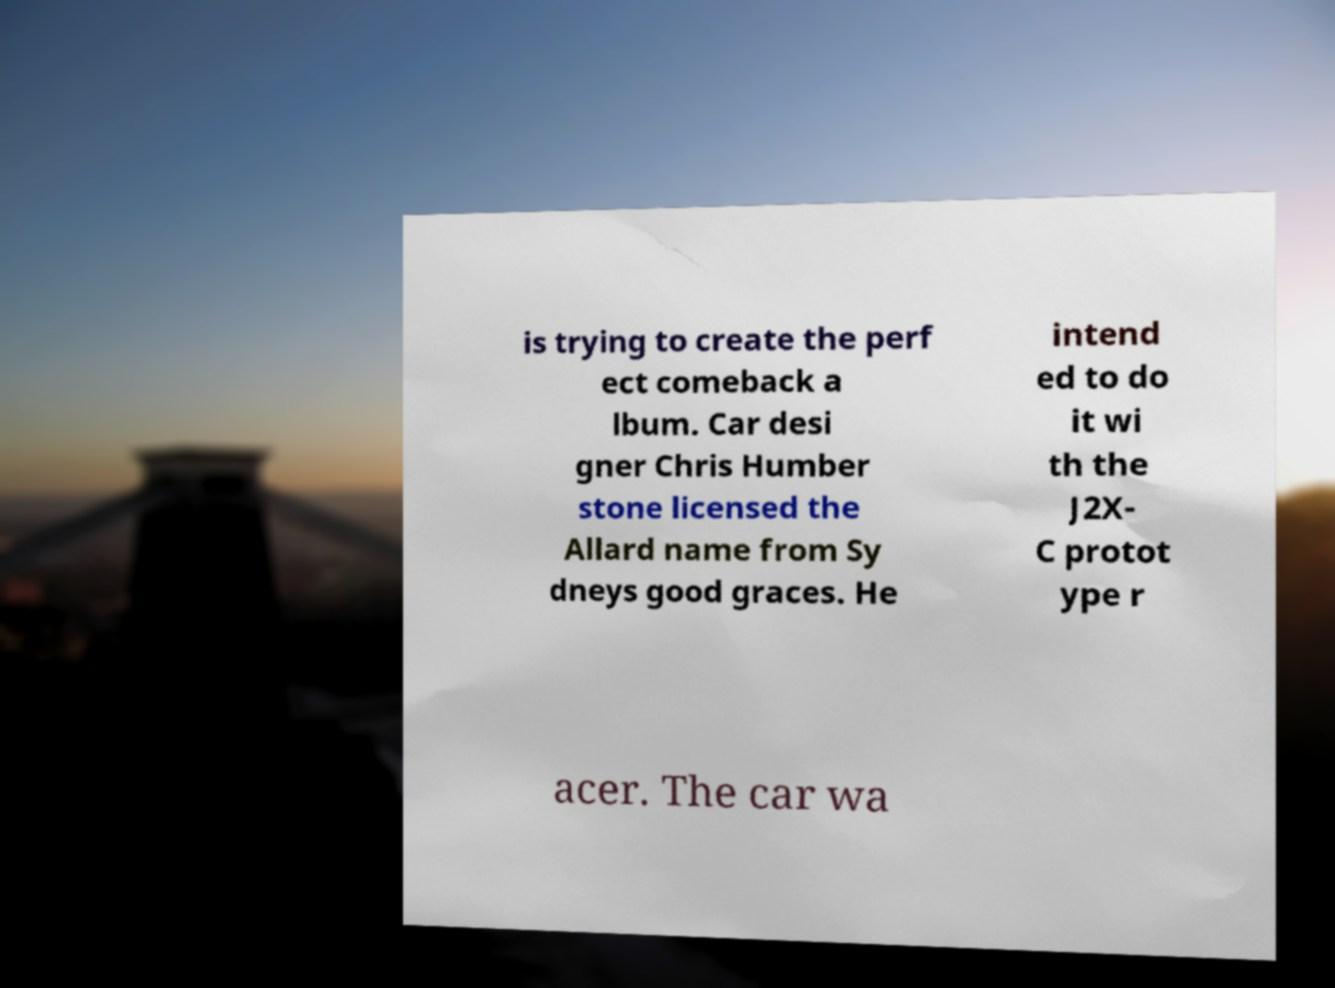Can you read and provide the text displayed in the image?This photo seems to have some interesting text. Can you extract and type it out for me? is trying to create the perf ect comeback a lbum. Car desi gner Chris Humber stone licensed the Allard name from Sy dneys good graces. He intend ed to do it wi th the J2X- C protot ype r acer. The car wa 